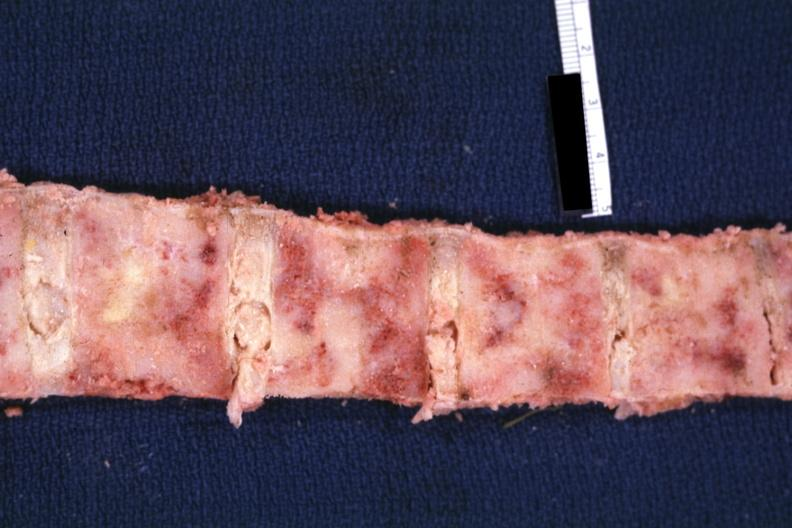what is present?
Answer the question using a single word or phrase. Joints 